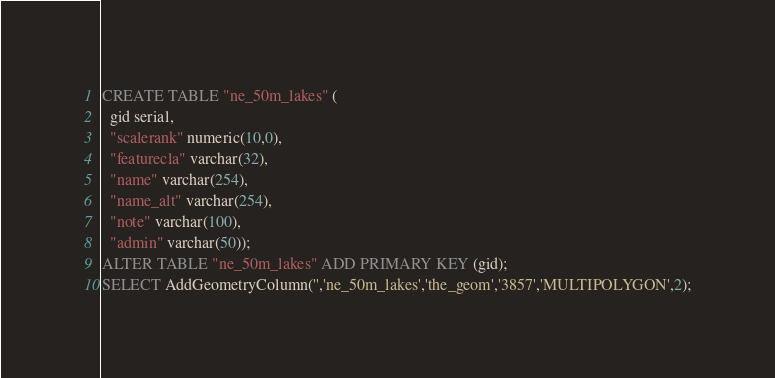Convert code to text. <code><loc_0><loc_0><loc_500><loc_500><_SQL_>
CREATE TABLE "ne_50m_lakes" (
  gid serial,
  "scalerank" numeric(10,0),
  "featurecla" varchar(32),
  "name" varchar(254),
  "name_alt" varchar(254),
  "note" varchar(100),
  "admin" varchar(50));
ALTER TABLE "ne_50m_lakes" ADD PRIMARY KEY (gid);
SELECT AddGeometryColumn('','ne_50m_lakes','the_geom','3857','MULTIPOLYGON',2);
</code> 